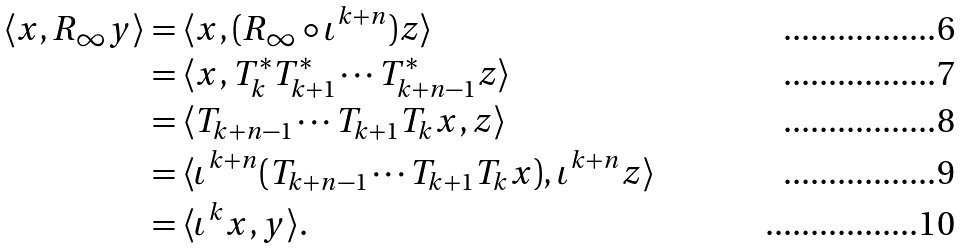<formula> <loc_0><loc_0><loc_500><loc_500>\langle x , R _ { \infty } y \rangle & = \langle x , ( R _ { \infty } \circ \iota ^ { k + n } ) z \rangle \\ & = \langle x , T _ { k } ^ { * } T _ { k + 1 } ^ { * } \cdots T _ { k + n - 1 } ^ { * } z \rangle \\ & = \langle T _ { k + n - 1 } \cdots T _ { k + 1 } T _ { k } x , z \rangle \\ & = \langle \iota ^ { k + n } ( T _ { k + n - 1 } \cdots T _ { k + 1 } T _ { k } x ) , \iota ^ { k + n } z \rangle \\ & = \langle \iota ^ { k } x , y \rangle .</formula> 